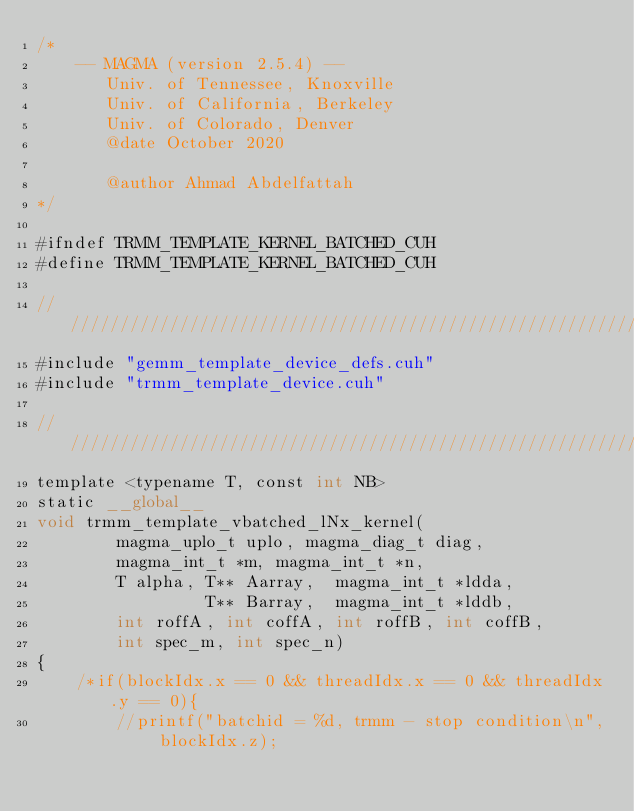Convert code to text. <code><loc_0><loc_0><loc_500><loc_500><_Cuda_>/*
    -- MAGMA (version 2.5.4) --
       Univ. of Tennessee, Knoxville
       Univ. of California, Berkeley
       Univ. of Colorado, Denver
       @date October 2020

       @author Ahmad Abdelfattah
*/

#ifndef TRMM_TEMPLATE_KERNEL_BATCHED_CUH
#define TRMM_TEMPLATE_KERNEL_BATCHED_CUH

////////////////////////////////////////////////////////////////////////////////////////////////////
#include "gemm_template_device_defs.cuh"
#include "trmm_template_device.cuh"

////////////////////////////////////////////////////////////////////////////////////////////////////
template <typename T, const int NB>
static __global__
void trmm_template_vbatched_lNx_kernel(
        magma_uplo_t uplo, magma_diag_t diag,
        magma_int_t *m, magma_int_t *n,
        T alpha, T** Aarray,  magma_int_t *ldda,
                 T** Barray,  magma_int_t *lddb,
        int roffA, int coffA, int roffB, int coffB,
        int spec_m, int spec_n)
{
    /*if(blockIdx.x == 0 && threadIdx.x == 0 && threadIdx.y == 0){
        //printf("batchid = %d, trmm - stop condition\n", blockIdx.z);</code> 